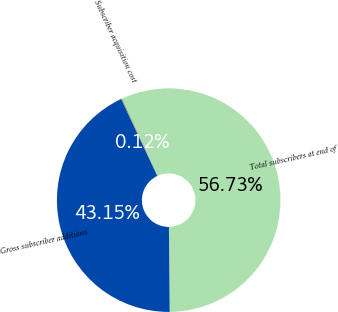Convert chart. <chart><loc_0><loc_0><loc_500><loc_500><pie_chart><fcel>Total subscribers at end of<fcel>Gross subscriber additions<fcel>Subscriber acquisition cost<nl><fcel>56.73%<fcel>43.15%<fcel>0.12%<nl></chart> 